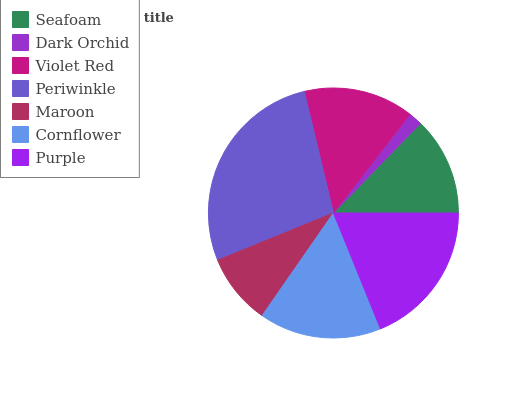Is Dark Orchid the minimum?
Answer yes or no. Yes. Is Periwinkle the maximum?
Answer yes or no. Yes. Is Violet Red the minimum?
Answer yes or no. No. Is Violet Red the maximum?
Answer yes or no. No. Is Violet Red greater than Dark Orchid?
Answer yes or no. Yes. Is Dark Orchid less than Violet Red?
Answer yes or no. Yes. Is Dark Orchid greater than Violet Red?
Answer yes or no. No. Is Violet Red less than Dark Orchid?
Answer yes or no. No. Is Violet Red the high median?
Answer yes or no. Yes. Is Violet Red the low median?
Answer yes or no. Yes. Is Cornflower the high median?
Answer yes or no. No. Is Periwinkle the low median?
Answer yes or no. No. 